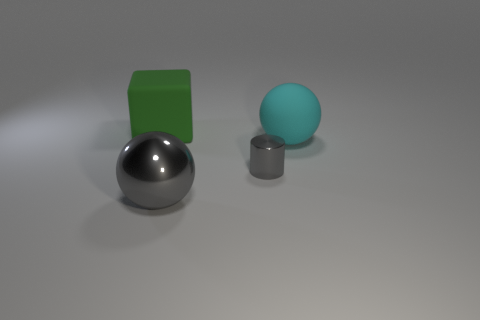There is a object in front of the cylinder; is its size the same as the small thing?
Your answer should be very brief. No. The large gray shiny object has what shape?
Keep it short and to the point. Sphere. How many matte things are the same shape as the small metallic object?
Offer a very short reply. 0. How many rubber things are on the left side of the cylinder and on the right side of the matte cube?
Your answer should be very brief. 0. What color is the large metallic object?
Give a very brief answer. Gray. Are there any big green things that have the same material as the gray cylinder?
Offer a terse response. No. There is a big sphere that is to the left of the gray thing that is behind the large gray shiny thing; is there a gray sphere in front of it?
Your answer should be very brief. No. Are there any big green cubes left of the shiny ball?
Ensure brevity in your answer.  Yes. Is there a large block that has the same color as the tiny object?
Your answer should be compact. No. What number of large things are either metallic balls or cyan matte spheres?
Offer a very short reply. 2. 